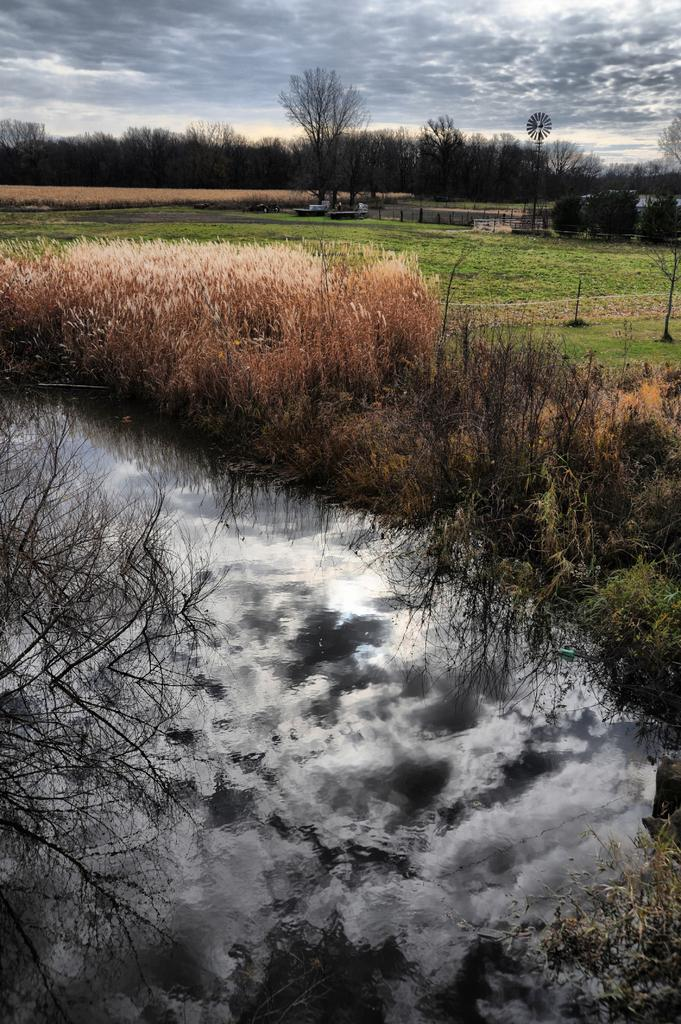What type of vegetation is present on the ground in the image? There are plants and grass on the ground in the image. What else can be seen besides the vegetation on the ground? There is water visible in the image. What is visible in the background of the image? There are trees in the background of the image. What is visible at the top of the image? The sky is visible at the top of the image. What can be seen in the sky? Clouds are present in the sky. How many lizards are sitting on the wall in the image? There is no wall or lizards present in the image. What type of beef is being cooked in the image? There is no beef or cooking activity present in the image. 